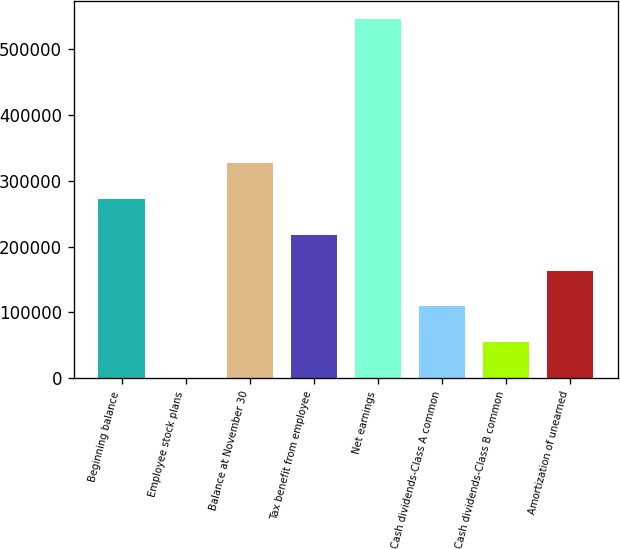Convert chart to OTSL. <chart><loc_0><loc_0><loc_500><loc_500><bar_chart><fcel>Beginning balance<fcel>Employee stock plans<fcel>Balance at November 30<fcel>Tax benefit from employee<fcel>Net earnings<fcel>Cash dividends-Class A common<fcel>Cash dividends-Class B common<fcel>Amortization of unearned<nl><fcel>272654<fcel>180<fcel>327149<fcel>218160<fcel>545129<fcel>109170<fcel>54674.9<fcel>163665<nl></chart> 